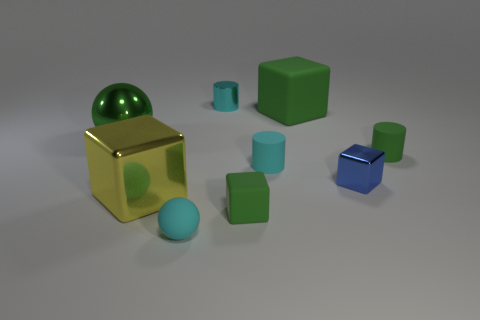Add 1 green metal balls. How many objects exist? 10 Subtract all big rubber blocks. How many blocks are left? 3 Subtract all cylinders. How many objects are left? 6 Subtract 2 spheres. How many spheres are left? 0 Subtract all green blocks. How many blocks are left? 2 Subtract all gray blocks. Subtract all blue spheres. How many blocks are left? 4 Subtract all brown cylinders. How many yellow blocks are left? 1 Subtract all large blue cubes. Subtract all large green matte objects. How many objects are left? 8 Add 9 yellow things. How many yellow things are left? 10 Add 1 small cyan matte balls. How many small cyan matte balls exist? 2 